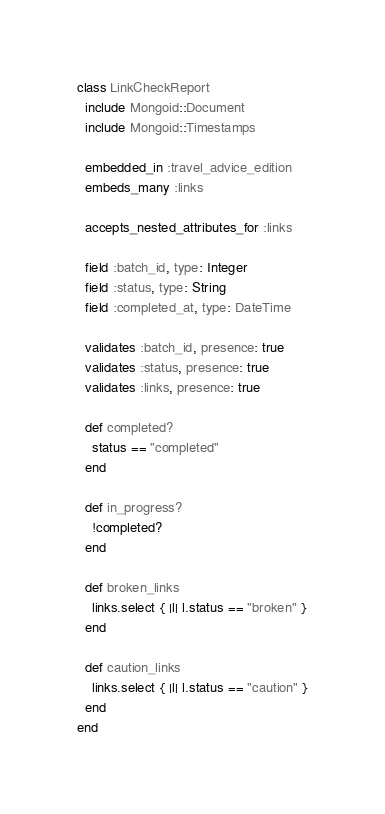<code> <loc_0><loc_0><loc_500><loc_500><_Ruby_>class LinkCheckReport
  include Mongoid::Document
  include Mongoid::Timestamps

  embedded_in :travel_advice_edition
  embeds_many :links

  accepts_nested_attributes_for :links

  field :batch_id, type: Integer
  field :status, type: String
  field :completed_at, type: DateTime

  validates :batch_id, presence: true
  validates :status, presence: true
  validates :links, presence: true

  def completed?
    status == "completed"
  end

  def in_progress?
    !completed?
  end

  def broken_links
    links.select { |l| l.status == "broken" }
  end

  def caution_links
    links.select { |l| l.status == "caution" }
  end
end
</code> 